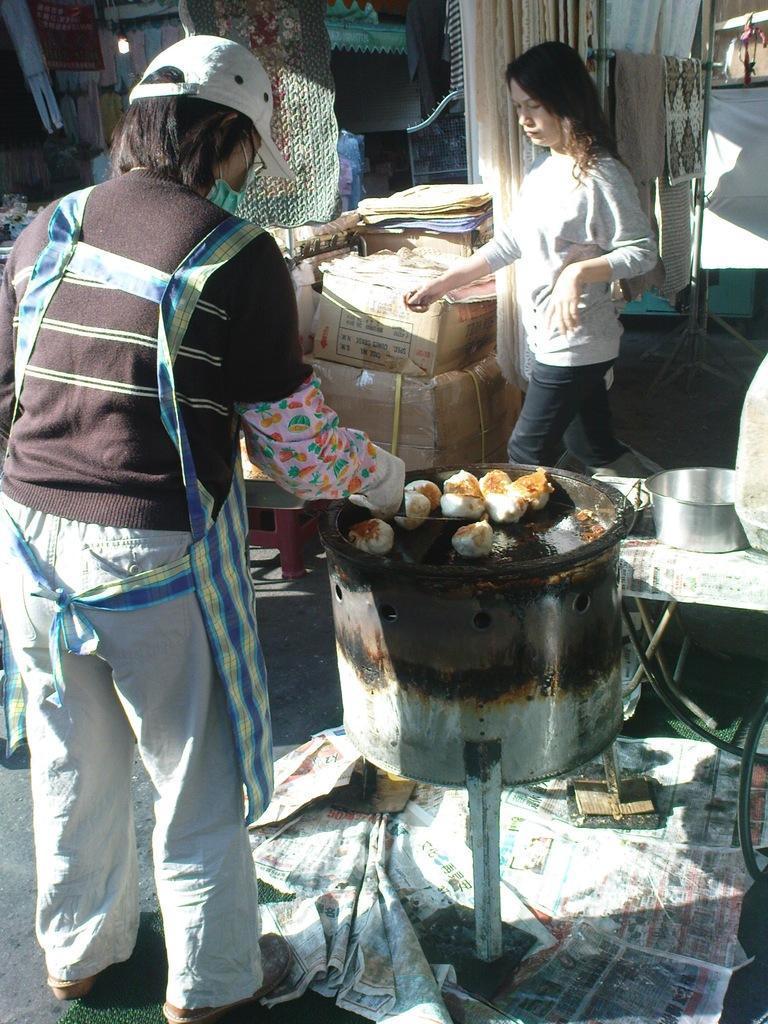Describe this image in one or two sentences. This is the picture of a person who is wearing the apron and standing in front of the stove on which there is some food item and to the side there is an other person, boxes and some other things. 